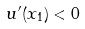Convert formula to latex. <formula><loc_0><loc_0><loc_500><loc_500>u ^ { \prime } ( x _ { 1 } ) < 0</formula> 